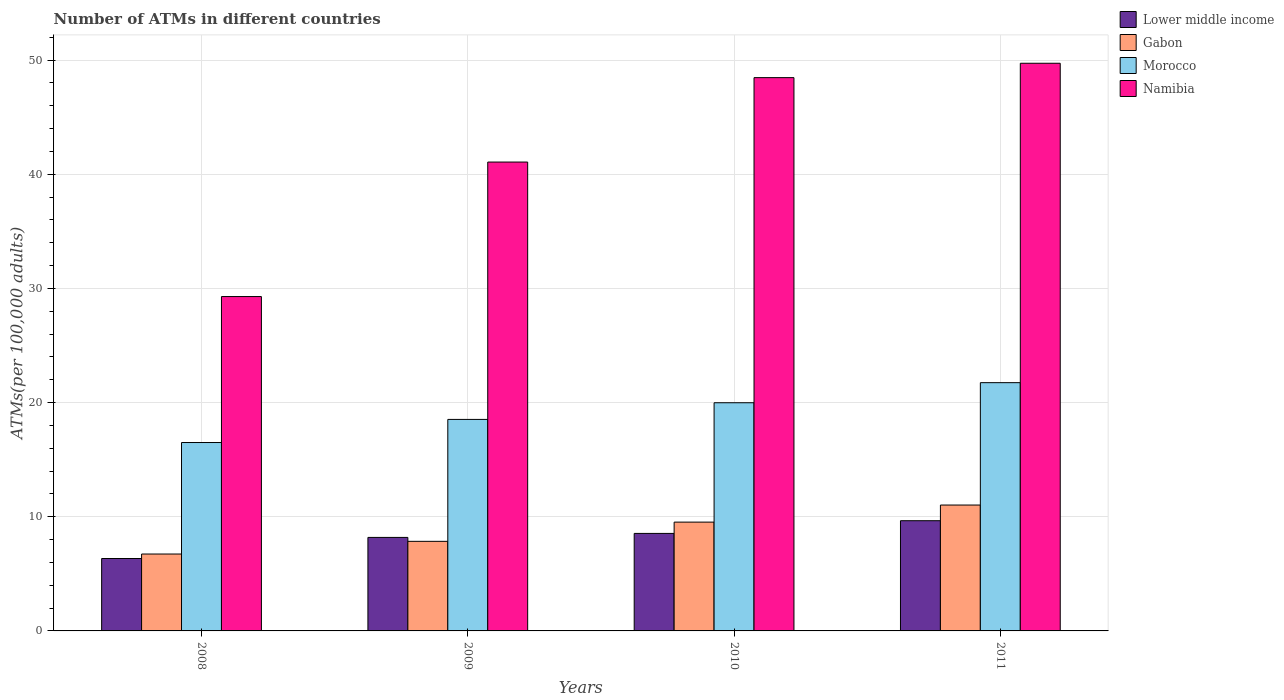How many different coloured bars are there?
Offer a terse response. 4. How many groups of bars are there?
Provide a short and direct response. 4. In how many cases, is the number of bars for a given year not equal to the number of legend labels?
Your answer should be compact. 0. What is the number of ATMs in Morocco in 2008?
Your answer should be compact. 16.5. Across all years, what is the maximum number of ATMs in Gabon?
Provide a short and direct response. 11.03. Across all years, what is the minimum number of ATMs in Morocco?
Offer a very short reply. 16.5. In which year was the number of ATMs in Gabon maximum?
Make the answer very short. 2011. What is the total number of ATMs in Morocco in the graph?
Give a very brief answer. 76.75. What is the difference between the number of ATMs in Namibia in 2008 and that in 2010?
Your answer should be very brief. -19.17. What is the difference between the number of ATMs in Gabon in 2011 and the number of ATMs in Lower middle income in 2009?
Give a very brief answer. 2.84. What is the average number of ATMs in Namibia per year?
Ensure brevity in your answer.  42.13. In the year 2010, what is the difference between the number of ATMs in Gabon and number of ATMs in Namibia?
Offer a terse response. -38.93. In how many years, is the number of ATMs in Gabon greater than 28?
Your answer should be very brief. 0. What is the ratio of the number of ATMs in Morocco in 2008 to that in 2010?
Your response must be concise. 0.83. Is the difference between the number of ATMs in Gabon in 2010 and 2011 greater than the difference between the number of ATMs in Namibia in 2010 and 2011?
Your answer should be very brief. No. What is the difference between the highest and the second highest number of ATMs in Lower middle income?
Provide a succinct answer. 1.11. What is the difference between the highest and the lowest number of ATMs in Namibia?
Your response must be concise. 20.43. Is the sum of the number of ATMs in Lower middle income in 2009 and 2010 greater than the maximum number of ATMs in Namibia across all years?
Offer a very short reply. No. Is it the case that in every year, the sum of the number of ATMs in Namibia and number of ATMs in Gabon is greater than the sum of number of ATMs in Morocco and number of ATMs in Lower middle income?
Provide a short and direct response. No. What does the 1st bar from the left in 2011 represents?
Your answer should be compact. Lower middle income. What does the 1st bar from the right in 2011 represents?
Your answer should be compact. Namibia. How many bars are there?
Your answer should be compact. 16. What is the difference between two consecutive major ticks on the Y-axis?
Your answer should be very brief. 10. Are the values on the major ticks of Y-axis written in scientific E-notation?
Your answer should be compact. No. Does the graph contain any zero values?
Offer a very short reply. No. Does the graph contain grids?
Give a very brief answer. Yes. How are the legend labels stacked?
Your answer should be compact. Vertical. What is the title of the graph?
Give a very brief answer. Number of ATMs in different countries. Does "North America" appear as one of the legend labels in the graph?
Keep it short and to the point. No. What is the label or title of the X-axis?
Provide a succinct answer. Years. What is the label or title of the Y-axis?
Provide a succinct answer. ATMs(per 100,0 adults). What is the ATMs(per 100,000 adults) of Lower middle income in 2008?
Give a very brief answer. 6.34. What is the ATMs(per 100,000 adults) in Gabon in 2008?
Ensure brevity in your answer.  6.73. What is the ATMs(per 100,000 adults) of Morocco in 2008?
Offer a very short reply. 16.5. What is the ATMs(per 100,000 adults) in Namibia in 2008?
Make the answer very short. 29.28. What is the ATMs(per 100,000 adults) in Lower middle income in 2009?
Give a very brief answer. 8.19. What is the ATMs(per 100,000 adults) of Gabon in 2009?
Offer a terse response. 7.85. What is the ATMs(per 100,000 adults) of Morocco in 2009?
Make the answer very short. 18.52. What is the ATMs(per 100,000 adults) of Namibia in 2009?
Your answer should be compact. 41.06. What is the ATMs(per 100,000 adults) in Lower middle income in 2010?
Offer a terse response. 8.54. What is the ATMs(per 100,000 adults) of Gabon in 2010?
Give a very brief answer. 9.53. What is the ATMs(per 100,000 adults) in Morocco in 2010?
Keep it short and to the point. 19.98. What is the ATMs(per 100,000 adults) of Namibia in 2010?
Offer a very short reply. 48.46. What is the ATMs(per 100,000 adults) of Lower middle income in 2011?
Give a very brief answer. 9.65. What is the ATMs(per 100,000 adults) of Gabon in 2011?
Offer a terse response. 11.03. What is the ATMs(per 100,000 adults) in Morocco in 2011?
Make the answer very short. 21.74. What is the ATMs(per 100,000 adults) in Namibia in 2011?
Make the answer very short. 49.72. Across all years, what is the maximum ATMs(per 100,000 adults) in Lower middle income?
Your response must be concise. 9.65. Across all years, what is the maximum ATMs(per 100,000 adults) of Gabon?
Give a very brief answer. 11.03. Across all years, what is the maximum ATMs(per 100,000 adults) of Morocco?
Ensure brevity in your answer.  21.74. Across all years, what is the maximum ATMs(per 100,000 adults) in Namibia?
Provide a short and direct response. 49.72. Across all years, what is the minimum ATMs(per 100,000 adults) in Lower middle income?
Provide a short and direct response. 6.34. Across all years, what is the minimum ATMs(per 100,000 adults) of Gabon?
Provide a short and direct response. 6.73. Across all years, what is the minimum ATMs(per 100,000 adults) in Morocco?
Offer a very short reply. 16.5. Across all years, what is the minimum ATMs(per 100,000 adults) of Namibia?
Your answer should be very brief. 29.28. What is the total ATMs(per 100,000 adults) in Lower middle income in the graph?
Your answer should be compact. 32.72. What is the total ATMs(per 100,000 adults) in Gabon in the graph?
Keep it short and to the point. 35.13. What is the total ATMs(per 100,000 adults) of Morocco in the graph?
Your response must be concise. 76.75. What is the total ATMs(per 100,000 adults) in Namibia in the graph?
Provide a succinct answer. 168.52. What is the difference between the ATMs(per 100,000 adults) in Lower middle income in 2008 and that in 2009?
Ensure brevity in your answer.  -1.85. What is the difference between the ATMs(per 100,000 adults) in Gabon in 2008 and that in 2009?
Your answer should be compact. -1.11. What is the difference between the ATMs(per 100,000 adults) of Morocco in 2008 and that in 2009?
Your answer should be very brief. -2.02. What is the difference between the ATMs(per 100,000 adults) of Namibia in 2008 and that in 2009?
Your answer should be very brief. -11.78. What is the difference between the ATMs(per 100,000 adults) of Lower middle income in 2008 and that in 2010?
Offer a terse response. -2.2. What is the difference between the ATMs(per 100,000 adults) in Gabon in 2008 and that in 2010?
Give a very brief answer. -2.79. What is the difference between the ATMs(per 100,000 adults) of Morocco in 2008 and that in 2010?
Your answer should be compact. -3.48. What is the difference between the ATMs(per 100,000 adults) of Namibia in 2008 and that in 2010?
Your response must be concise. -19.17. What is the difference between the ATMs(per 100,000 adults) of Lower middle income in 2008 and that in 2011?
Make the answer very short. -3.31. What is the difference between the ATMs(per 100,000 adults) in Gabon in 2008 and that in 2011?
Offer a very short reply. -4.29. What is the difference between the ATMs(per 100,000 adults) of Morocco in 2008 and that in 2011?
Offer a very short reply. -5.24. What is the difference between the ATMs(per 100,000 adults) in Namibia in 2008 and that in 2011?
Offer a very short reply. -20.43. What is the difference between the ATMs(per 100,000 adults) in Lower middle income in 2009 and that in 2010?
Your response must be concise. -0.35. What is the difference between the ATMs(per 100,000 adults) of Gabon in 2009 and that in 2010?
Your answer should be compact. -1.68. What is the difference between the ATMs(per 100,000 adults) in Morocco in 2009 and that in 2010?
Your response must be concise. -1.46. What is the difference between the ATMs(per 100,000 adults) of Namibia in 2009 and that in 2010?
Keep it short and to the point. -7.39. What is the difference between the ATMs(per 100,000 adults) of Lower middle income in 2009 and that in 2011?
Make the answer very short. -1.46. What is the difference between the ATMs(per 100,000 adults) of Gabon in 2009 and that in 2011?
Your answer should be compact. -3.18. What is the difference between the ATMs(per 100,000 adults) of Morocco in 2009 and that in 2011?
Give a very brief answer. -3.22. What is the difference between the ATMs(per 100,000 adults) in Namibia in 2009 and that in 2011?
Keep it short and to the point. -8.65. What is the difference between the ATMs(per 100,000 adults) of Lower middle income in 2010 and that in 2011?
Ensure brevity in your answer.  -1.11. What is the difference between the ATMs(per 100,000 adults) of Gabon in 2010 and that in 2011?
Offer a terse response. -1.5. What is the difference between the ATMs(per 100,000 adults) in Morocco in 2010 and that in 2011?
Your answer should be compact. -1.76. What is the difference between the ATMs(per 100,000 adults) of Namibia in 2010 and that in 2011?
Your answer should be compact. -1.26. What is the difference between the ATMs(per 100,000 adults) in Lower middle income in 2008 and the ATMs(per 100,000 adults) in Gabon in 2009?
Keep it short and to the point. -1.5. What is the difference between the ATMs(per 100,000 adults) of Lower middle income in 2008 and the ATMs(per 100,000 adults) of Morocco in 2009?
Your answer should be very brief. -12.18. What is the difference between the ATMs(per 100,000 adults) of Lower middle income in 2008 and the ATMs(per 100,000 adults) of Namibia in 2009?
Give a very brief answer. -34.72. What is the difference between the ATMs(per 100,000 adults) of Gabon in 2008 and the ATMs(per 100,000 adults) of Morocco in 2009?
Keep it short and to the point. -11.79. What is the difference between the ATMs(per 100,000 adults) in Gabon in 2008 and the ATMs(per 100,000 adults) in Namibia in 2009?
Give a very brief answer. -34.33. What is the difference between the ATMs(per 100,000 adults) of Morocco in 2008 and the ATMs(per 100,000 adults) of Namibia in 2009?
Provide a succinct answer. -24.56. What is the difference between the ATMs(per 100,000 adults) in Lower middle income in 2008 and the ATMs(per 100,000 adults) in Gabon in 2010?
Your answer should be very brief. -3.19. What is the difference between the ATMs(per 100,000 adults) of Lower middle income in 2008 and the ATMs(per 100,000 adults) of Morocco in 2010?
Your answer should be compact. -13.64. What is the difference between the ATMs(per 100,000 adults) in Lower middle income in 2008 and the ATMs(per 100,000 adults) in Namibia in 2010?
Make the answer very short. -42.11. What is the difference between the ATMs(per 100,000 adults) of Gabon in 2008 and the ATMs(per 100,000 adults) of Morocco in 2010?
Provide a succinct answer. -13.25. What is the difference between the ATMs(per 100,000 adults) in Gabon in 2008 and the ATMs(per 100,000 adults) in Namibia in 2010?
Provide a short and direct response. -41.72. What is the difference between the ATMs(per 100,000 adults) of Morocco in 2008 and the ATMs(per 100,000 adults) of Namibia in 2010?
Give a very brief answer. -31.96. What is the difference between the ATMs(per 100,000 adults) of Lower middle income in 2008 and the ATMs(per 100,000 adults) of Gabon in 2011?
Ensure brevity in your answer.  -4.68. What is the difference between the ATMs(per 100,000 adults) of Lower middle income in 2008 and the ATMs(per 100,000 adults) of Morocco in 2011?
Provide a short and direct response. -15.4. What is the difference between the ATMs(per 100,000 adults) of Lower middle income in 2008 and the ATMs(per 100,000 adults) of Namibia in 2011?
Ensure brevity in your answer.  -43.37. What is the difference between the ATMs(per 100,000 adults) in Gabon in 2008 and the ATMs(per 100,000 adults) in Morocco in 2011?
Offer a terse response. -15.01. What is the difference between the ATMs(per 100,000 adults) in Gabon in 2008 and the ATMs(per 100,000 adults) in Namibia in 2011?
Give a very brief answer. -42.98. What is the difference between the ATMs(per 100,000 adults) of Morocco in 2008 and the ATMs(per 100,000 adults) of Namibia in 2011?
Provide a succinct answer. -33.22. What is the difference between the ATMs(per 100,000 adults) of Lower middle income in 2009 and the ATMs(per 100,000 adults) of Gabon in 2010?
Keep it short and to the point. -1.34. What is the difference between the ATMs(per 100,000 adults) in Lower middle income in 2009 and the ATMs(per 100,000 adults) in Morocco in 2010?
Provide a short and direct response. -11.8. What is the difference between the ATMs(per 100,000 adults) of Lower middle income in 2009 and the ATMs(per 100,000 adults) of Namibia in 2010?
Your answer should be compact. -40.27. What is the difference between the ATMs(per 100,000 adults) in Gabon in 2009 and the ATMs(per 100,000 adults) in Morocco in 2010?
Your answer should be very brief. -12.14. What is the difference between the ATMs(per 100,000 adults) in Gabon in 2009 and the ATMs(per 100,000 adults) in Namibia in 2010?
Provide a short and direct response. -40.61. What is the difference between the ATMs(per 100,000 adults) in Morocco in 2009 and the ATMs(per 100,000 adults) in Namibia in 2010?
Provide a succinct answer. -29.93. What is the difference between the ATMs(per 100,000 adults) in Lower middle income in 2009 and the ATMs(per 100,000 adults) in Gabon in 2011?
Your answer should be compact. -2.84. What is the difference between the ATMs(per 100,000 adults) of Lower middle income in 2009 and the ATMs(per 100,000 adults) of Morocco in 2011?
Your answer should be compact. -13.55. What is the difference between the ATMs(per 100,000 adults) in Lower middle income in 2009 and the ATMs(per 100,000 adults) in Namibia in 2011?
Make the answer very short. -41.53. What is the difference between the ATMs(per 100,000 adults) of Gabon in 2009 and the ATMs(per 100,000 adults) of Morocco in 2011?
Offer a terse response. -13.9. What is the difference between the ATMs(per 100,000 adults) of Gabon in 2009 and the ATMs(per 100,000 adults) of Namibia in 2011?
Provide a succinct answer. -41.87. What is the difference between the ATMs(per 100,000 adults) of Morocco in 2009 and the ATMs(per 100,000 adults) of Namibia in 2011?
Keep it short and to the point. -31.19. What is the difference between the ATMs(per 100,000 adults) of Lower middle income in 2010 and the ATMs(per 100,000 adults) of Gabon in 2011?
Your response must be concise. -2.49. What is the difference between the ATMs(per 100,000 adults) of Lower middle income in 2010 and the ATMs(per 100,000 adults) of Morocco in 2011?
Your answer should be very brief. -13.2. What is the difference between the ATMs(per 100,000 adults) of Lower middle income in 2010 and the ATMs(per 100,000 adults) of Namibia in 2011?
Your answer should be very brief. -41.18. What is the difference between the ATMs(per 100,000 adults) of Gabon in 2010 and the ATMs(per 100,000 adults) of Morocco in 2011?
Provide a short and direct response. -12.21. What is the difference between the ATMs(per 100,000 adults) in Gabon in 2010 and the ATMs(per 100,000 adults) in Namibia in 2011?
Make the answer very short. -40.19. What is the difference between the ATMs(per 100,000 adults) in Morocco in 2010 and the ATMs(per 100,000 adults) in Namibia in 2011?
Provide a short and direct response. -29.73. What is the average ATMs(per 100,000 adults) of Lower middle income per year?
Your answer should be compact. 8.18. What is the average ATMs(per 100,000 adults) of Gabon per year?
Offer a very short reply. 8.78. What is the average ATMs(per 100,000 adults) in Morocco per year?
Keep it short and to the point. 19.19. What is the average ATMs(per 100,000 adults) of Namibia per year?
Your answer should be compact. 42.13. In the year 2008, what is the difference between the ATMs(per 100,000 adults) in Lower middle income and ATMs(per 100,000 adults) in Gabon?
Your answer should be very brief. -0.39. In the year 2008, what is the difference between the ATMs(per 100,000 adults) of Lower middle income and ATMs(per 100,000 adults) of Morocco?
Keep it short and to the point. -10.16. In the year 2008, what is the difference between the ATMs(per 100,000 adults) of Lower middle income and ATMs(per 100,000 adults) of Namibia?
Offer a terse response. -22.94. In the year 2008, what is the difference between the ATMs(per 100,000 adults) of Gabon and ATMs(per 100,000 adults) of Morocco?
Provide a succinct answer. -9.77. In the year 2008, what is the difference between the ATMs(per 100,000 adults) in Gabon and ATMs(per 100,000 adults) in Namibia?
Make the answer very short. -22.55. In the year 2008, what is the difference between the ATMs(per 100,000 adults) in Morocco and ATMs(per 100,000 adults) in Namibia?
Offer a terse response. -12.78. In the year 2009, what is the difference between the ATMs(per 100,000 adults) of Lower middle income and ATMs(per 100,000 adults) of Gabon?
Your answer should be compact. 0.34. In the year 2009, what is the difference between the ATMs(per 100,000 adults) of Lower middle income and ATMs(per 100,000 adults) of Morocco?
Provide a succinct answer. -10.33. In the year 2009, what is the difference between the ATMs(per 100,000 adults) in Lower middle income and ATMs(per 100,000 adults) in Namibia?
Offer a terse response. -32.87. In the year 2009, what is the difference between the ATMs(per 100,000 adults) of Gabon and ATMs(per 100,000 adults) of Morocco?
Offer a terse response. -10.68. In the year 2009, what is the difference between the ATMs(per 100,000 adults) of Gabon and ATMs(per 100,000 adults) of Namibia?
Your answer should be compact. -33.22. In the year 2009, what is the difference between the ATMs(per 100,000 adults) of Morocco and ATMs(per 100,000 adults) of Namibia?
Provide a short and direct response. -22.54. In the year 2010, what is the difference between the ATMs(per 100,000 adults) of Lower middle income and ATMs(per 100,000 adults) of Gabon?
Make the answer very short. -0.99. In the year 2010, what is the difference between the ATMs(per 100,000 adults) of Lower middle income and ATMs(per 100,000 adults) of Morocco?
Make the answer very short. -11.44. In the year 2010, what is the difference between the ATMs(per 100,000 adults) in Lower middle income and ATMs(per 100,000 adults) in Namibia?
Give a very brief answer. -39.92. In the year 2010, what is the difference between the ATMs(per 100,000 adults) in Gabon and ATMs(per 100,000 adults) in Morocco?
Your response must be concise. -10.46. In the year 2010, what is the difference between the ATMs(per 100,000 adults) in Gabon and ATMs(per 100,000 adults) in Namibia?
Offer a terse response. -38.93. In the year 2010, what is the difference between the ATMs(per 100,000 adults) of Morocco and ATMs(per 100,000 adults) of Namibia?
Provide a short and direct response. -28.47. In the year 2011, what is the difference between the ATMs(per 100,000 adults) in Lower middle income and ATMs(per 100,000 adults) in Gabon?
Provide a short and direct response. -1.37. In the year 2011, what is the difference between the ATMs(per 100,000 adults) of Lower middle income and ATMs(per 100,000 adults) of Morocco?
Give a very brief answer. -12.09. In the year 2011, what is the difference between the ATMs(per 100,000 adults) in Lower middle income and ATMs(per 100,000 adults) in Namibia?
Your answer should be very brief. -40.06. In the year 2011, what is the difference between the ATMs(per 100,000 adults) in Gabon and ATMs(per 100,000 adults) in Morocco?
Ensure brevity in your answer.  -10.72. In the year 2011, what is the difference between the ATMs(per 100,000 adults) of Gabon and ATMs(per 100,000 adults) of Namibia?
Keep it short and to the point. -38.69. In the year 2011, what is the difference between the ATMs(per 100,000 adults) of Morocco and ATMs(per 100,000 adults) of Namibia?
Provide a short and direct response. -27.97. What is the ratio of the ATMs(per 100,000 adults) of Lower middle income in 2008 to that in 2009?
Offer a terse response. 0.77. What is the ratio of the ATMs(per 100,000 adults) of Gabon in 2008 to that in 2009?
Offer a very short reply. 0.86. What is the ratio of the ATMs(per 100,000 adults) in Morocco in 2008 to that in 2009?
Your answer should be compact. 0.89. What is the ratio of the ATMs(per 100,000 adults) of Namibia in 2008 to that in 2009?
Ensure brevity in your answer.  0.71. What is the ratio of the ATMs(per 100,000 adults) of Lower middle income in 2008 to that in 2010?
Your answer should be compact. 0.74. What is the ratio of the ATMs(per 100,000 adults) of Gabon in 2008 to that in 2010?
Offer a terse response. 0.71. What is the ratio of the ATMs(per 100,000 adults) of Morocco in 2008 to that in 2010?
Provide a succinct answer. 0.83. What is the ratio of the ATMs(per 100,000 adults) of Namibia in 2008 to that in 2010?
Offer a terse response. 0.6. What is the ratio of the ATMs(per 100,000 adults) of Lower middle income in 2008 to that in 2011?
Offer a terse response. 0.66. What is the ratio of the ATMs(per 100,000 adults) of Gabon in 2008 to that in 2011?
Provide a succinct answer. 0.61. What is the ratio of the ATMs(per 100,000 adults) of Morocco in 2008 to that in 2011?
Ensure brevity in your answer.  0.76. What is the ratio of the ATMs(per 100,000 adults) of Namibia in 2008 to that in 2011?
Offer a terse response. 0.59. What is the ratio of the ATMs(per 100,000 adults) in Lower middle income in 2009 to that in 2010?
Give a very brief answer. 0.96. What is the ratio of the ATMs(per 100,000 adults) of Gabon in 2009 to that in 2010?
Offer a terse response. 0.82. What is the ratio of the ATMs(per 100,000 adults) of Morocco in 2009 to that in 2010?
Your answer should be very brief. 0.93. What is the ratio of the ATMs(per 100,000 adults) in Namibia in 2009 to that in 2010?
Ensure brevity in your answer.  0.85. What is the ratio of the ATMs(per 100,000 adults) of Lower middle income in 2009 to that in 2011?
Your answer should be very brief. 0.85. What is the ratio of the ATMs(per 100,000 adults) in Gabon in 2009 to that in 2011?
Keep it short and to the point. 0.71. What is the ratio of the ATMs(per 100,000 adults) in Morocco in 2009 to that in 2011?
Offer a terse response. 0.85. What is the ratio of the ATMs(per 100,000 adults) of Namibia in 2009 to that in 2011?
Offer a terse response. 0.83. What is the ratio of the ATMs(per 100,000 adults) in Lower middle income in 2010 to that in 2011?
Provide a succinct answer. 0.88. What is the ratio of the ATMs(per 100,000 adults) of Gabon in 2010 to that in 2011?
Offer a very short reply. 0.86. What is the ratio of the ATMs(per 100,000 adults) in Morocco in 2010 to that in 2011?
Offer a terse response. 0.92. What is the ratio of the ATMs(per 100,000 adults) in Namibia in 2010 to that in 2011?
Your answer should be very brief. 0.97. What is the difference between the highest and the second highest ATMs(per 100,000 adults) of Lower middle income?
Your response must be concise. 1.11. What is the difference between the highest and the second highest ATMs(per 100,000 adults) of Gabon?
Make the answer very short. 1.5. What is the difference between the highest and the second highest ATMs(per 100,000 adults) of Morocco?
Provide a short and direct response. 1.76. What is the difference between the highest and the second highest ATMs(per 100,000 adults) in Namibia?
Give a very brief answer. 1.26. What is the difference between the highest and the lowest ATMs(per 100,000 adults) of Lower middle income?
Offer a terse response. 3.31. What is the difference between the highest and the lowest ATMs(per 100,000 adults) of Gabon?
Provide a succinct answer. 4.29. What is the difference between the highest and the lowest ATMs(per 100,000 adults) of Morocco?
Offer a very short reply. 5.24. What is the difference between the highest and the lowest ATMs(per 100,000 adults) of Namibia?
Your response must be concise. 20.43. 